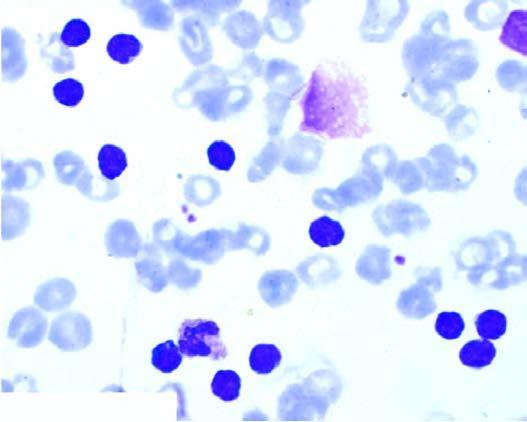s some degenerate forms appearing as bare smudged nuclei?
Answer the question using a single word or phrase. Yes 